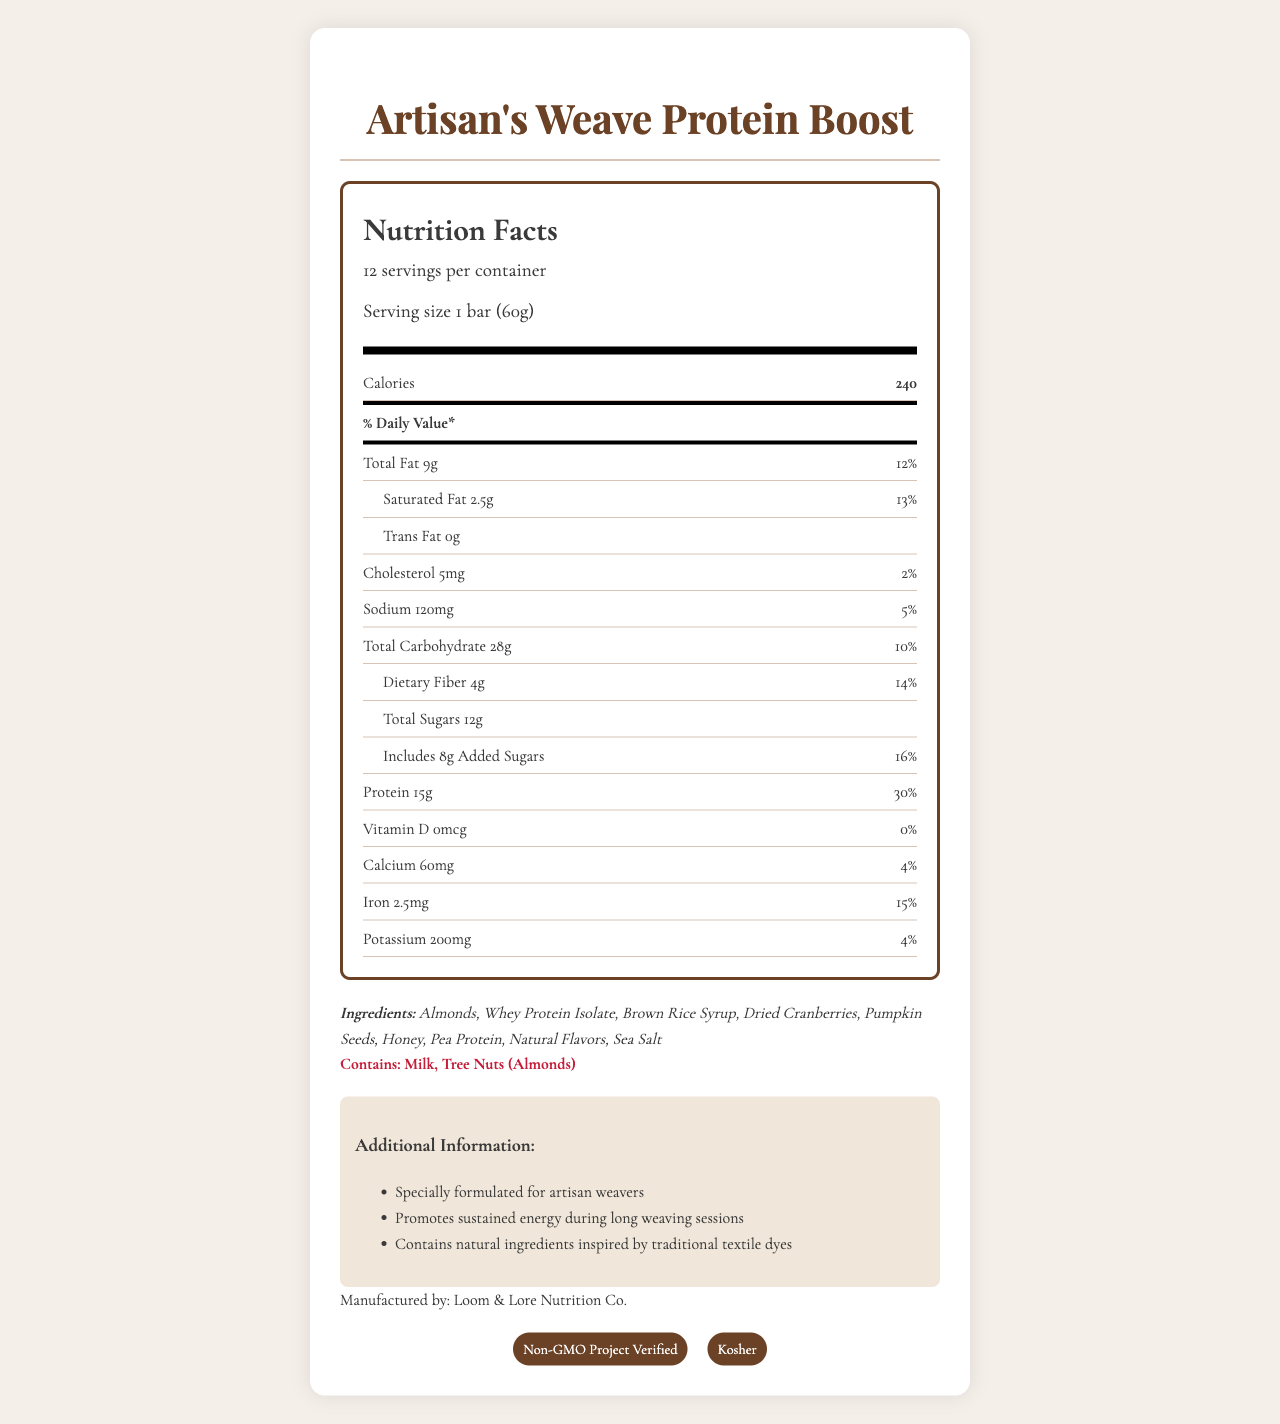What is the calorie count per serving? The document specifies that each serving of the "Artisan's Weave Protein Boost" contains 240 calories.
Answer: 240 calories How much protein is in one serving? The nutrition facts indicate that each serving contains 15 grams of protein, which is 30% of the daily value.
Answer: 15 grams What is the serving size for the "Artisan's Weave Protein Boost"? The document states that the serving size is 1 bar, which weighs 60 grams.
Answer: 1 bar (60g) How many servings are there in one container? The document specifies that there are 12 servings per container.
Answer: 12 servings List the main ingredients in the snack bar. The ingredients list on the document provides the main components of the snack bar.
Answer: Almonds, Whey Protein Isolate, Brown Rice Syrup, Dried Cranberries, Pumpkin Seeds, Honey, Pea Protein, Natural Flavors, Sea Salt Multiple-choice: How much sodium does one bar contain? I. 100mg II. 200mg III. 120mg IV. 150mg According to the document, one bar contains 120mg of sodium, which is 5% of the daily value.
Answer: III. 120mg Multiple-choice: Which of the following vitamins or minerals is present in the highest daily value percentage? A. Calcium B. Iron C. Vitamin D D. Potassium The document shows iron at 15% of the daily value, which is higher than the daily values for calcium (4%), potassium (4%), and vitamin D (0%).
Answer: B. Iron Does the product contain any tree nuts? The allergens section clearly states that the product contains tree nuts (Almonds).
Answer: Yes Is the "Artisan's Weave Protein Boost" Kosher certified? The document lists Kosher as one of the certifications.
Answer: Yes Summarize the additional information provided about the product. The document contains a section stating that the product is designed for artisan weavers, supports sustained energy, and includes natural ingredients related to traditional textile dyes.
Answer: The "Artisan's Weave Protein Boost" is specially formulated for artisan weavers and promotes sustained energy during long weaving sessions. It contains natural ingredients inspired by traditional textile dyes. What is the total amount of sugars in one serving? The document indicates that there are 12 grams of total sugars in one serving.
Answer: 12 grams How much added sugars are included in one bar? The document states that one bar includes 8 grams of added sugars, which amounts to 16% of the daily value.
Answer: 8 grams What is the fat content in one serving? According to the document, each serving contains 9 grams of total fat.
Answer: 9 grams Can the exact number of calories from fat be determined from the document alone? The document does not provide the exact number of calories from fat; it only states the total fat content in grams.
Answer: Not enough information Who manufactures the "Artisan's Weave Protein Boost"? The document lists Loom & Lore Nutrition Co. as the manufacturer.
Answer: Loom & Lore Nutrition Co. Is there any trans fat in the snack bar? The document specifies that the snack bar contains 0 grams of trans fat.
Answer: No 